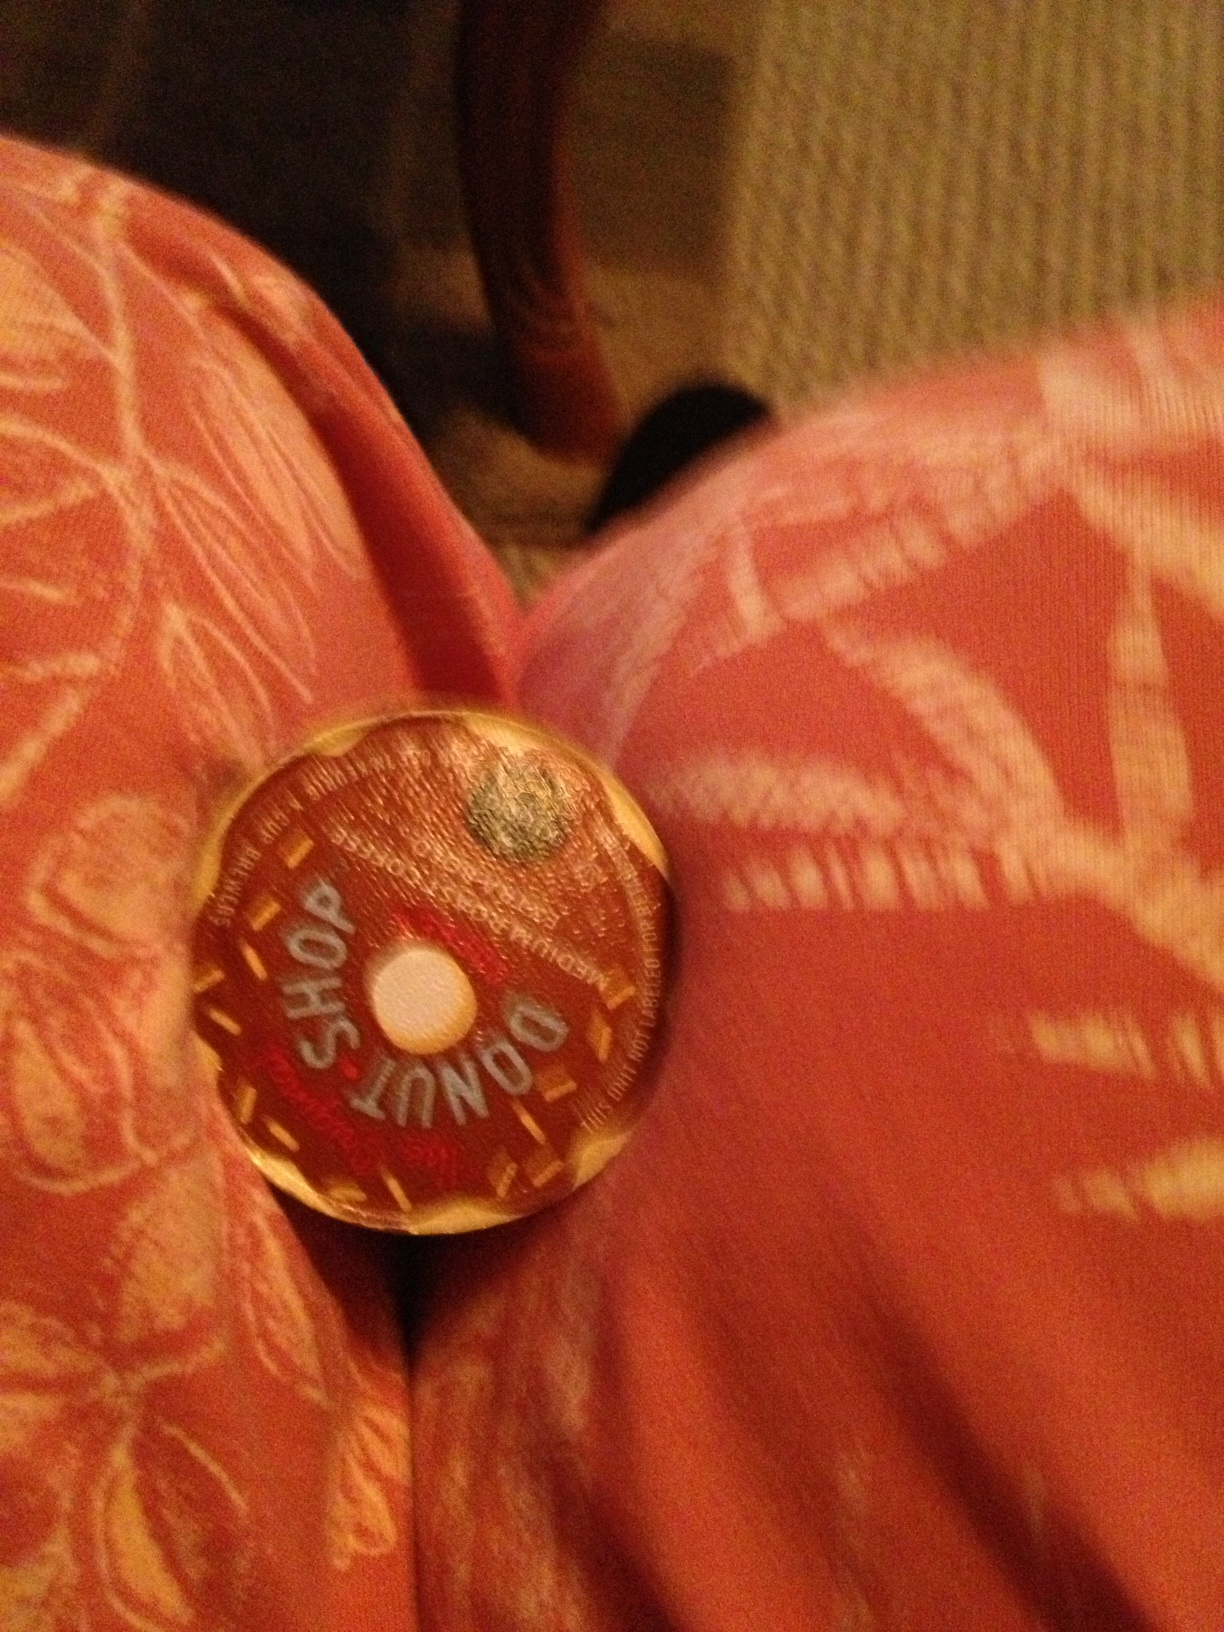Could this coffee pod belong to a magical coffee maker that brews differently flavored coffees based on your mood? Absolutely! Imagine a whimsical coffee maker that reads your mood and changes the flavor of your coffee accordingly. Feeling happy? It brews a bright, citrusy blend that invigorates your senses. Feeling nostalgic? A warm, caramel-flavored roast appears, making you feel like you’re back in your favorite childhood bakery. Feeling adventurous? How about a surprising twist of chocolate and chili to spark your morning? 